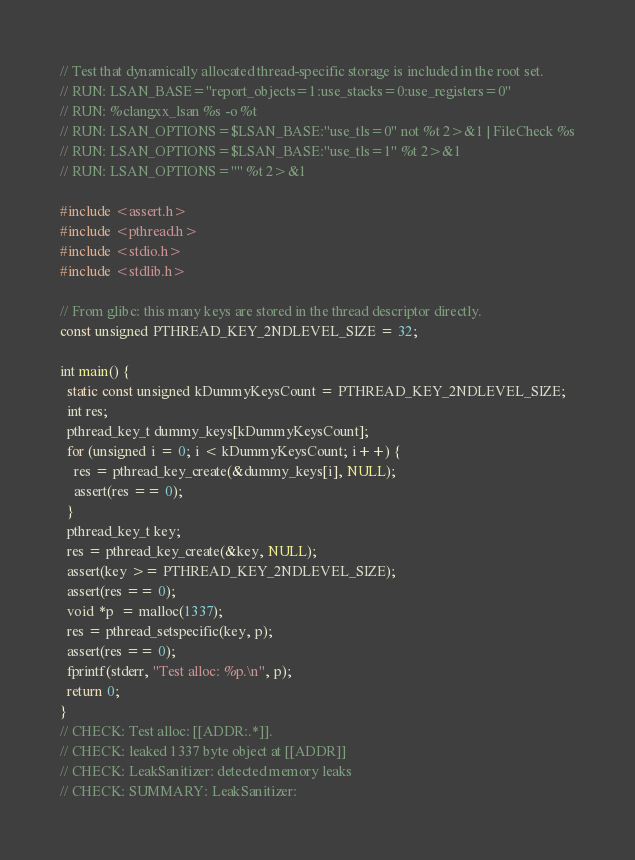Convert code to text. <code><loc_0><loc_0><loc_500><loc_500><_C++_>// Test that dynamically allocated thread-specific storage is included in the root set.
// RUN: LSAN_BASE="report_objects=1:use_stacks=0:use_registers=0"
// RUN: %clangxx_lsan %s -o %t
// RUN: LSAN_OPTIONS=$LSAN_BASE:"use_tls=0" not %t 2>&1 | FileCheck %s
// RUN: LSAN_OPTIONS=$LSAN_BASE:"use_tls=1" %t 2>&1
// RUN: LSAN_OPTIONS="" %t 2>&1

#include <assert.h>
#include <pthread.h>
#include <stdio.h>
#include <stdlib.h>

// From glibc: this many keys are stored in the thread descriptor directly.
const unsigned PTHREAD_KEY_2NDLEVEL_SIZE = 32;

int main() {
  static const unsigned kDummyKeysCount = PTHREAD_KEY_2NDLEVEL_SIZE;
  int res;
  pthread_key_t dummy_keys[kDummyKeysCount];
  for (unsigned i = 0; i < kDummyKeysCount; i++) {
    res = pthread_key_create(&dummy_keys[i], NULL);
    assert(res == 0);
  }
  pthread_key_t key;
  res = pthread_key_create(&key, NULL);
  assert(key >= PTHREAD_KEY_2NDLEVEL_SIZE);
  assert(res == 0);
  void *p  = malloc(1337);
  res = pthread_setspecific(key, p);
  assert(res == 0);
  fprintf(stderr, "Test alloc: %p.\n", p);
  return 0;
}
// CHECK: Test alloc: [[ADDR:.*]].
// CHECK: leaked 1337 byte object at [[ADDR]]
// CHECK: LeakSanitizer: detected memory leaks
// CHECK: SUMMARY: LeakSanitizer:
</code> 